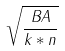Convert formula to latex. <formula><loc_0><loc_0><loc_500><loc_500>\sqrt { \frac { B A } { k * n } }</formula> 